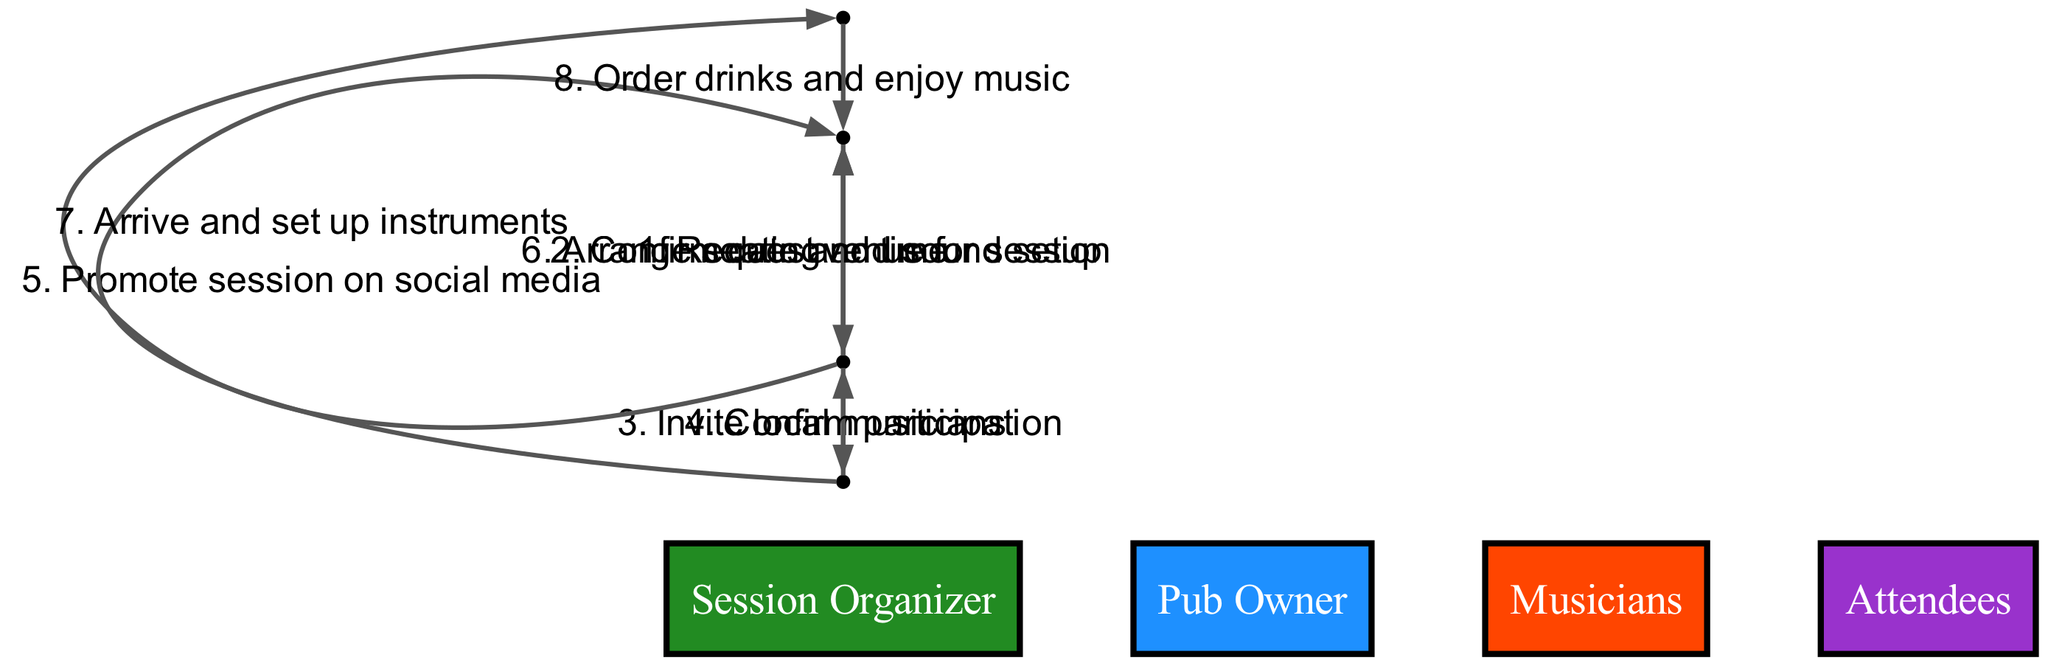What is the first action in the sequence? The first action in the sequence is the "Request venue for session," which is initiated by the "Session Organizer." This is identified as the first entry in the sequence list.
Answer: Request venue for session How many actors are involved in the diagram? The diagram lists four different actors: "Session Organizer," "Pub Owner," "Musicians," and "Attendees." Simply counting the distinct names gives the total number of actors.
Answer: 4 What action does the "Pub Owner" take after receiving the request? After receiving the request from the "Session Organizer," the "Pub Owner" takes the action to "Confirm date and time." This can be traced directly from the transfer of action from the "Session Organizer" to the "Pub Owner."
Answer: Confirm date and time Which actor is responsible for promoting the session? The "Session Organizer" is responsible for promoting the session by taking the action "Promote session on social media." This is indicated by the sequence flow leading from the "Session Organizer" to "Attendees."
Answer: Session Organizer How do the "Musicians" interact with the "Pub Owner"? The "Musicians" interact with the "Pub Owner" by arriving and setting up their instruments. This action follows their confirmation of participation with the "Session Organizer" and indicates their engagement with the venue owner.
Answer: Arrive and set up instruments What is the last action that occurs in the sequence? The last action in the sequence is "Order drinks and enjoy music," which is performed by the "Attendees." It is positioned as the final action in the diagram, confirming it is last.
Answer: Order drinks and enjoy music How does the sequence of actions flow from the "Session Organizer" to the "Attendees"? The sequence flows from the "Session Organizer" to the "Attendees" through actions of inviting musicians and promoting the session on social media. Initially, the "Session Organizer" invites musicians and then promotes the session, leading to attendee engagement.
Answer: Through inviting musicians and promoting the session What is the relationship between the "Musicians" and the "Session Organizer"? The relationship is that the "Musicians" confirm their participation after being invited by the "Session Organizer." This interaction shows a flow of communication and agreement between them.
Answer: Confirm participation 